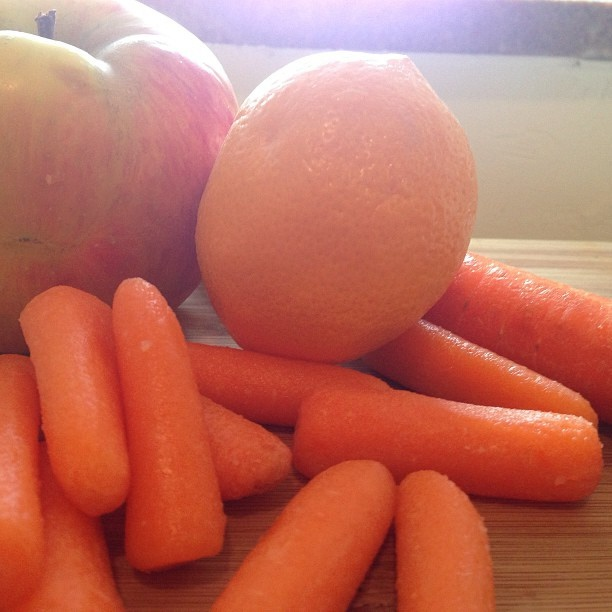Describe the objects in this image and their specific colors. I can see orange in tan, lightpink, salmon, and brown tones, apple in tan, brown, lightpink, and white tones, carrot in tan, red, and brown tones, carrot in tan, brown, red, and salmon tones, and carrot in tan, red, brown, and salmon tones in this image. 